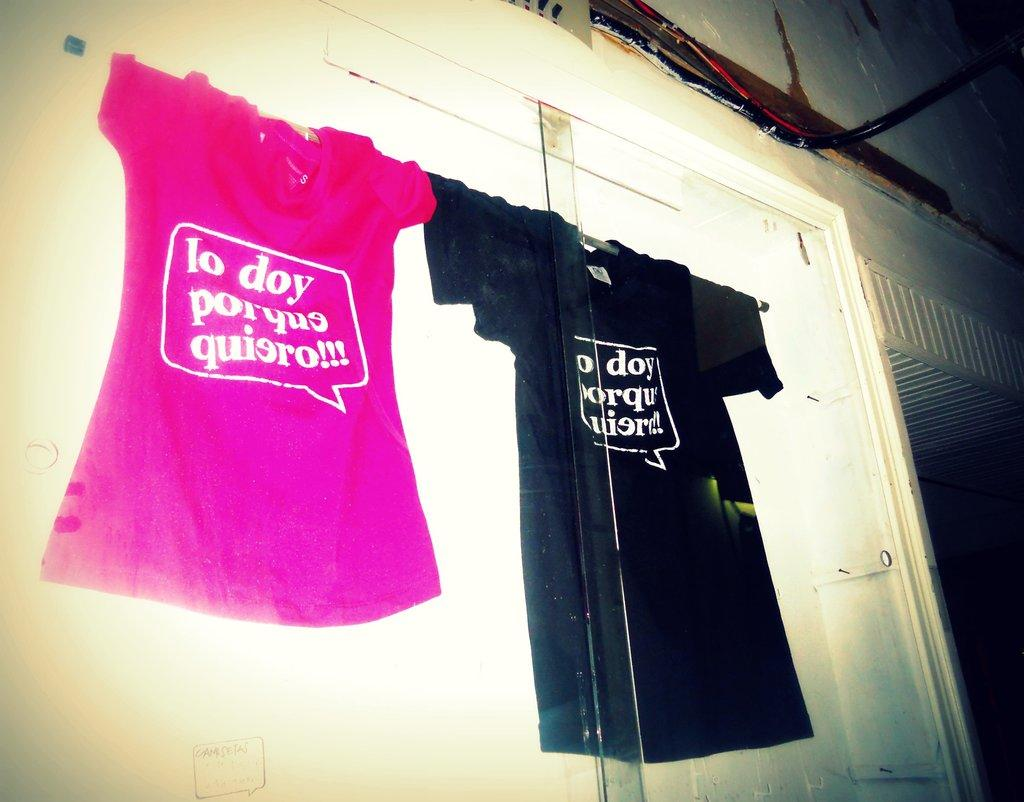<image>
Render a clear and concise summary of the photo. two tee shirts, one pink one black, with lo doy as the first line 